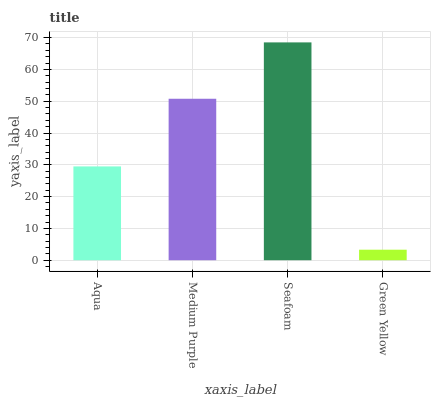Is Green Yellow the minimum?
Answer yes or no. Yes. Is Seafoam the maximum?
Answer yes or no. Yes. Is Medium Purple the minimum?
Answer yes or no. No. Is Medium Purple the maximum?
Answer yes or no. No. Is Medium Purple greater than Aqua?
Answer yes or no. Yes. Is Aqua less than Medium Purple?
Answer yes or no. Yes. Is Aqua greater than Medium Purple?
Answer yes or no. No. Is Medium Purple less than Aqua?
Answer yes or no. No. Is Medium Purple the high median?
Answer yes or no. Yes. Is Aqua the low median?
Answer yes or no. Yes. Is Aqua the high median?
Answer yes or no. No. Is Seafoam the low median?
Answer yes or no. No. 